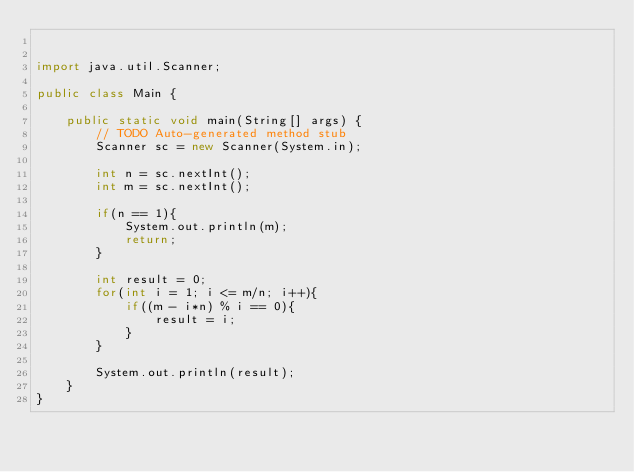<code> <loc_0><loc_0><loc_500><loc_500><_Java_>

import java.util.Scanner;

public class Main {

	public static void main(String[] args) {
		// TODO Auto-generated method stub
		Scanner sc = new Scanner(System.in);

		int n = sc.nextInt();
		int m = sc.nextInt();

		if(n == 1){
			System.out.println(m);
			return;
		}

		int result = 0;
		for(int i = 1; i <= m/n; i++){
			if((m - i*n) % i == 0){
				result = i;
			}
		}

		System.out.println(result);
	}
}
</code> 